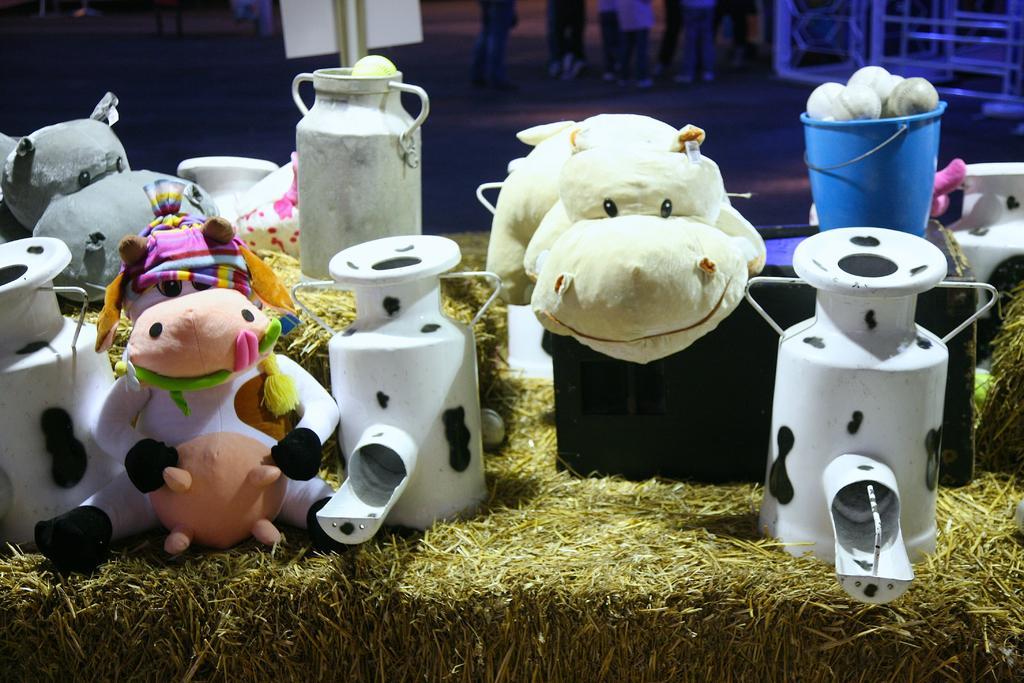Can you describe this image briefly? This picture is consists of model of a farmhouse. 